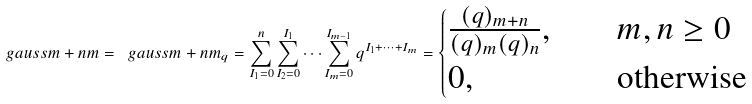Convert formula to latex. <formula><loc_0><loc_0><loc_500><loc_500>\ g a u s s { m + n } { m } = \ g a u s s { m + n } { m } _ { q } = \sum _ { I _ { 1 } = 0 } ^ { n } \sum _ { I _ { 2 } = 0 } ^ { I _ { 1 } } \cdots \sum _ { I _ { m } = 0 } ^ { I _ { m - 1 } } q ^ { I _ { 1 } + \dots + I _ { m } } = \begin{cases} \frac { ( q ) _ { m + n } } { ( q ) _ { m } ( q ) _ { n } } , & \quad m , n \geq 0 \\ 0 , & \quad \text {otherwise} \\ \end{cases}</formula> 